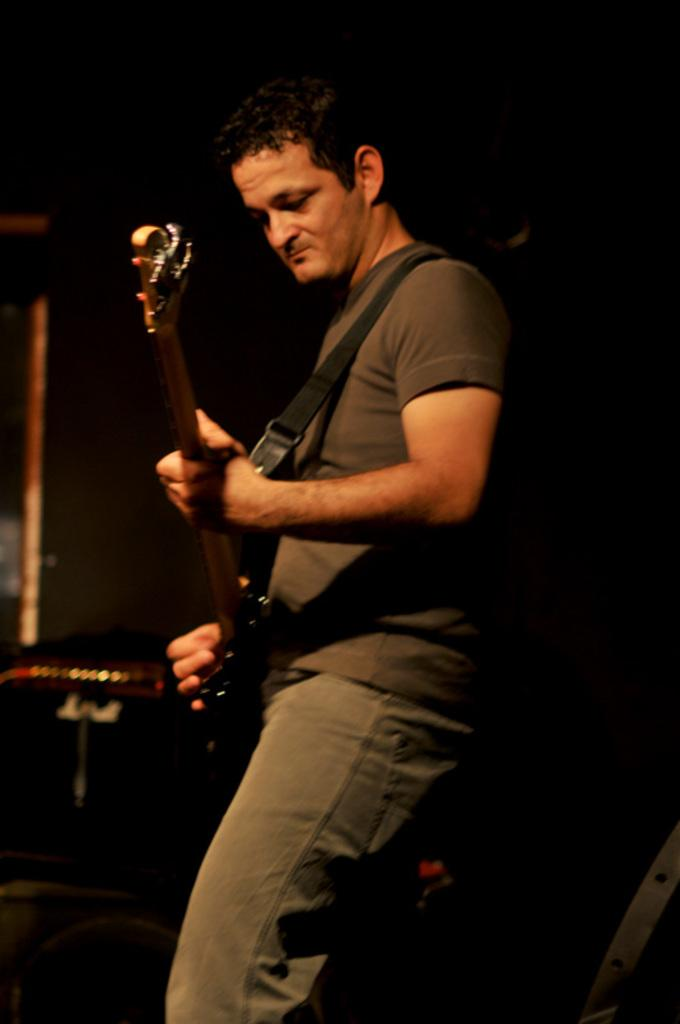What is the main subject of the image? There is a person in the image. What is the person doing in the image? The person is standing in the image. What object is the person holding in the image? The person is holding a guitar in the image. What type of net can be seen in the image? There is no net present in the image. What kind of noise is being made by the person in the image? The image does not provide any information about noise being made by the person. 